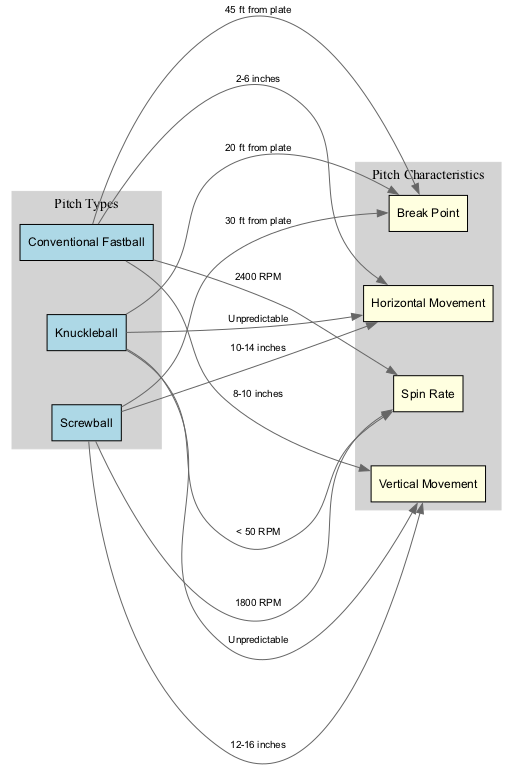What is the spin rate of the Conventional Fastball? The edge connecting the Conventional Fastball node to the Spin Rate node shows the label "2400 RPM". Therefore, the spin rate for this pitch is directly provided in the diagram.
Answer: 2400 RPM What is the break point distance of the Knuckleball? The edge from the Knuckleball node to the Break Point node has the label "20 ft from plate", which gives the direct information requested.
Answer: 20 ft from plate How many different pitches are represented in the diagram? By counting the nodes in the "Pitch Types" subgraph, we see three pitches: Conventional Fastball, Knuckleball, and Screwball, indicating the number of unique pitches in the diagram.
Answer: 3 What is the vertical movement of the Screwball? The edge leading from the Screwball node to the Vertical Movement node shows the label "12-16 inches", providing the specific information needed for the question.
Answer: 12-16 inches Which pitch has the most unpredictable vertical movement? By comparing the vertical movement entries, the Knuckleball is labeled "Unpredictable", indicating that it does not follow a defined pattern like the other pitches. Therefore, it can be identified as the one with the most unpredictable vertical movement.
Answer: Unpredictable What is the horizontal movement of the Conventional Fastball? The edge from the Conventional Fastball node to the Horizontal Movement node shows the range "2-6 inches". Thus, it gives clear information about the horizontal movement of this pitch.
Answer: 2-6 inches Which unconventional pitch has the lowest spin rate? The Knuckleball has a spin rate labeled as "< 50 RPM". By comparing with the other spin rates in the diagram, it is clear that this one is the lowest among the listed pitches.
Answer: < 50 RPM What type of diagram is this? The diagram visually compares different types of pitches and their characteristics, primarily focusing on the comparisons of spin rates and break points; this centers on data relations and attributes of the pitches, thus identifying it as a Graduate Level Diagram.
Answer: Graduate Level Diagram 